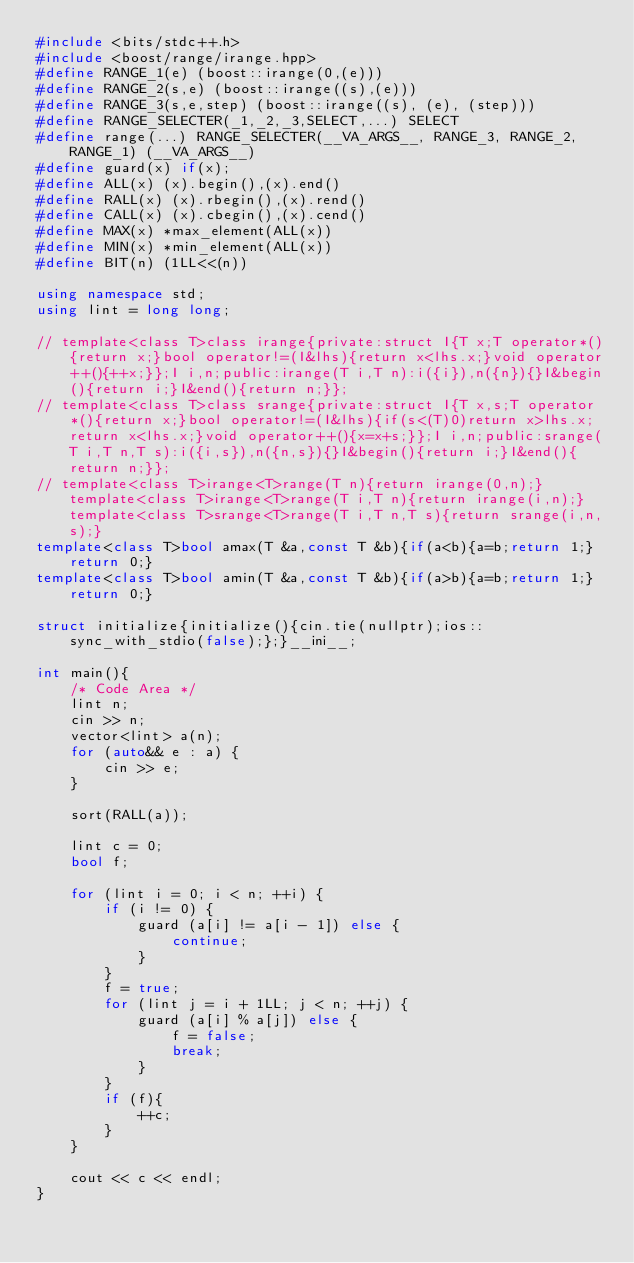<code> <loc_0><loc_0><loc_500><loc_500><_C++_>#include <bits/stdc++.h>
#include <boost/range/irange.hpp>
#define RANGE_1(e) (boost::irange(0,(e)))
#define RANGE_2(s,e) (boost::irange((s),(e)))
#define RANGE_3(s,e,step) (boost::irange((s), (e), (step)))
#define RANGE_SELECTER(_1,_2,_3,SELECT,...) SELECT
#define range(...) RANGE_SELECTER(__VA_ARGS__, RANGE_3, RANGE_2, RANGE_1) (__VA_ARGS__)
#define guard(x) if(x);
#define ALL(x) (x).begin(),(x).end()
#define RALL(x) (x).rbegin(),(x).rend()
#define CALL(x) (x).cbegin(),(x).cend()
#define MAX(x) *max_element(ALL(x))
#define MIN(x) *min_element(ALL(x))
#define BIT(n) (1LL<<(n))

using namespace std;
using lint = long long;

// template<class T>class irange{private:struct I{T x;T operator*(){return x;}bool operator!=(I&lhs){return x<lhs.x;}void operator++(){++x;}};I i,n;public:irange(T i,T n):i({i}),n({n}){}I&begin(){return i;}I&end(){return n;}};
// template<class T>class srange{private:struct I{T x,s;T operator*(){return x;}bool operator!=(I&lhs){if(s<(T)0)return x>lhs.x;return x<lhs.x;}void operator++(){x=x+s;}};I i,n;public:srange(T i,T n,T s):i({i,s}),n({n,s}){}I&begin(){return i;}I&end(){return n;}};
// template<class T>irange<T>range(T n){return irange(0,n);}template<class T>irange<T>range(T i,T n){return irange(i,n);}template<class T>srange<T>range(T i,T n,T s){return srange(i,n,s);}
template<class T>bool amax(T &a,const T &b){if(a<b){a=b;return 1;}return 0;}
template<class T>bool amin(T &a,const T &b){if(a>b){a=b;return 1;}return 0;}

struct initialize{initialize(){cin.tie(nullptr);ios::sync_with_stdio(false);};}__ini__;

int main(){
    /* Code Area */
    lint n;
    cin >> n;
    vector<lint> a(n);
    for (auto&& e : a) {
        cin >> e;
    }

    sort(RALL(a));

    lint c = 0;
    bool f;

    for (lint i = 0; i < n; ++i) {
        if (i != 0) {
            guard (a[i] != a[i - 1]) else {
                continue;
            }
        }
        f = true;
        for (lint j = i + 1LL; j < n; ++j) {
            guard (a[i] % a[j]) else {
                f = false;
                break;
            }
        }
        if (f){
            ++c;
        }
    }

    cout << c << endl;
}
</code> 